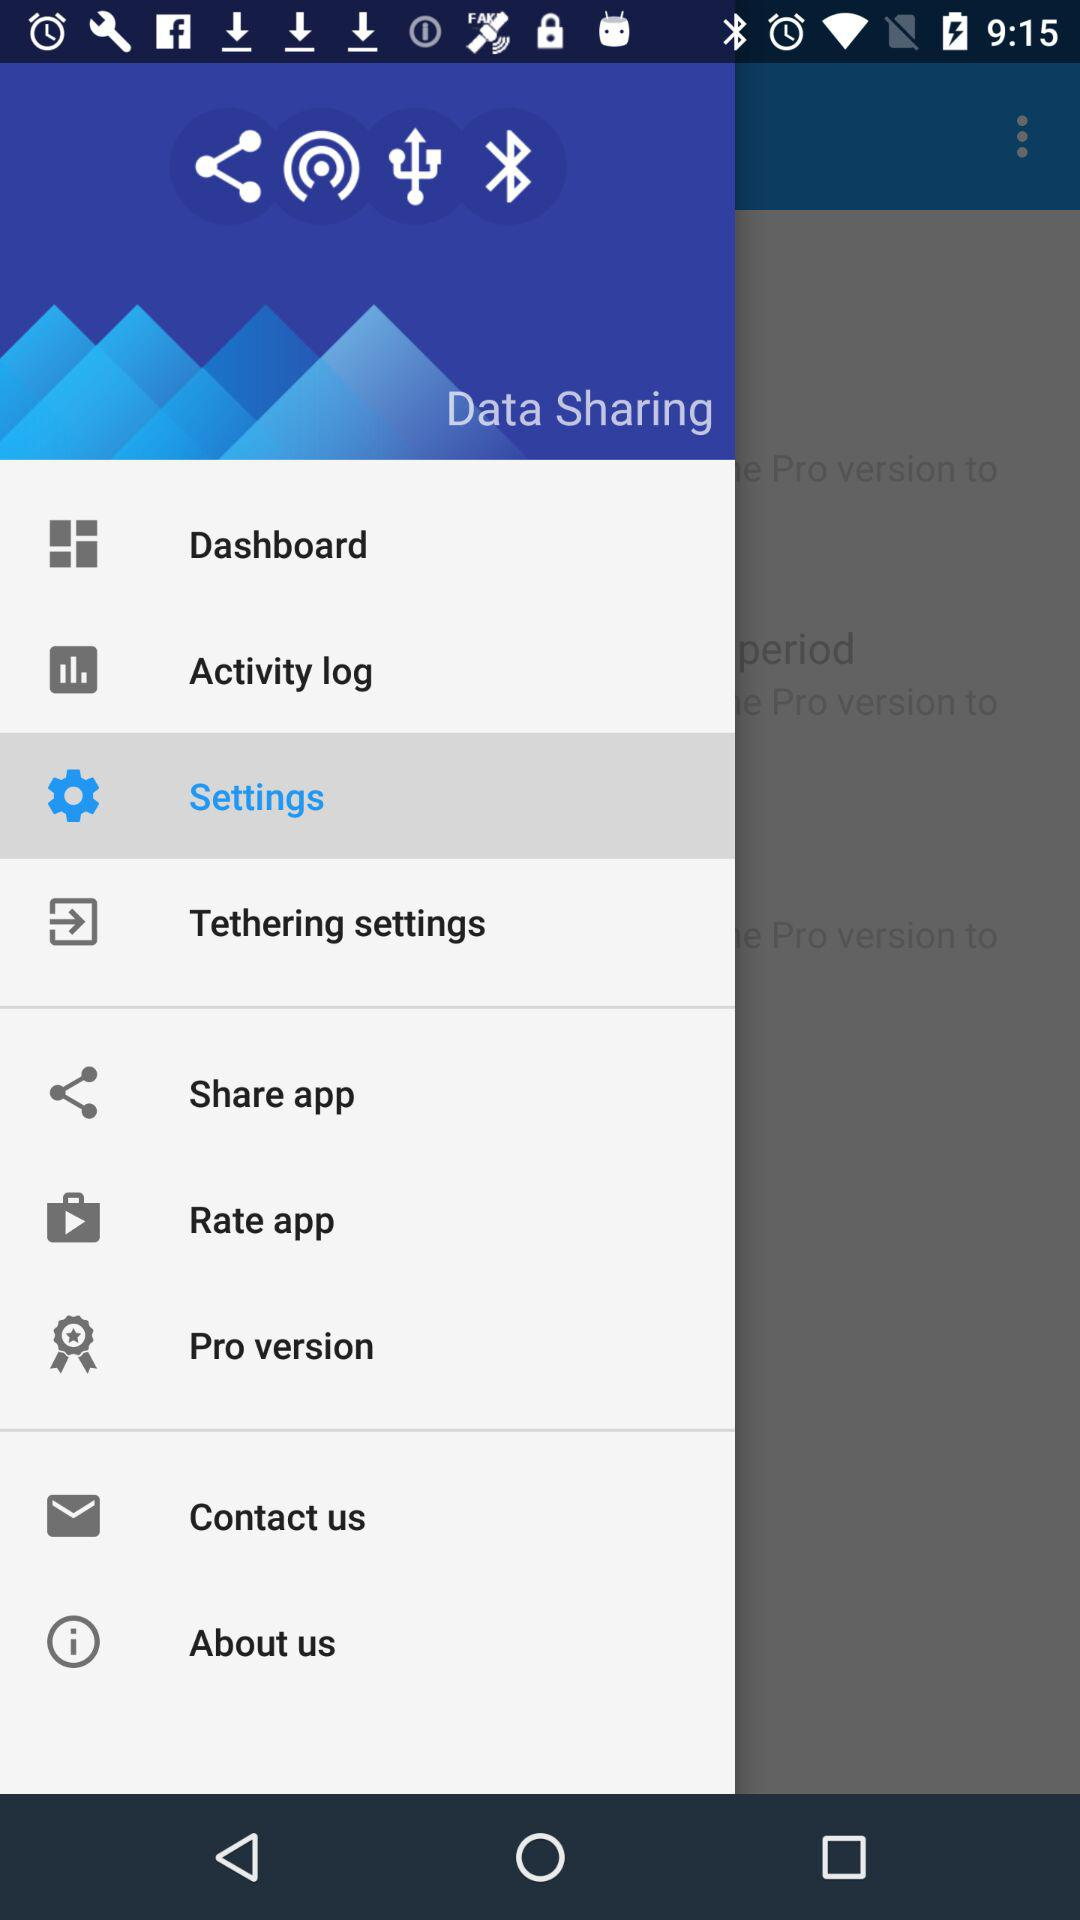What are the available sharing options?
When the provided information is insufficient, respond with <no answer>. <no answer> 